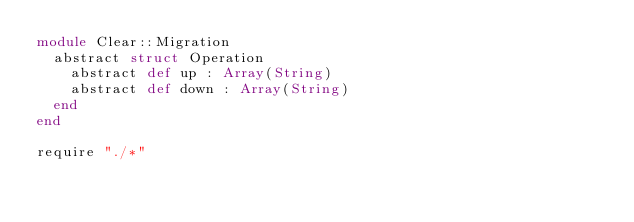Convert code to text. <code><loc_0><loc_0><loc_500><loc_500><_Crystal_>module Clear::Migration
  abstract struct Operation
    abstract def up : Array(String)
    abstract def down : Array(String)
  end
end

require "./*"
</code> 